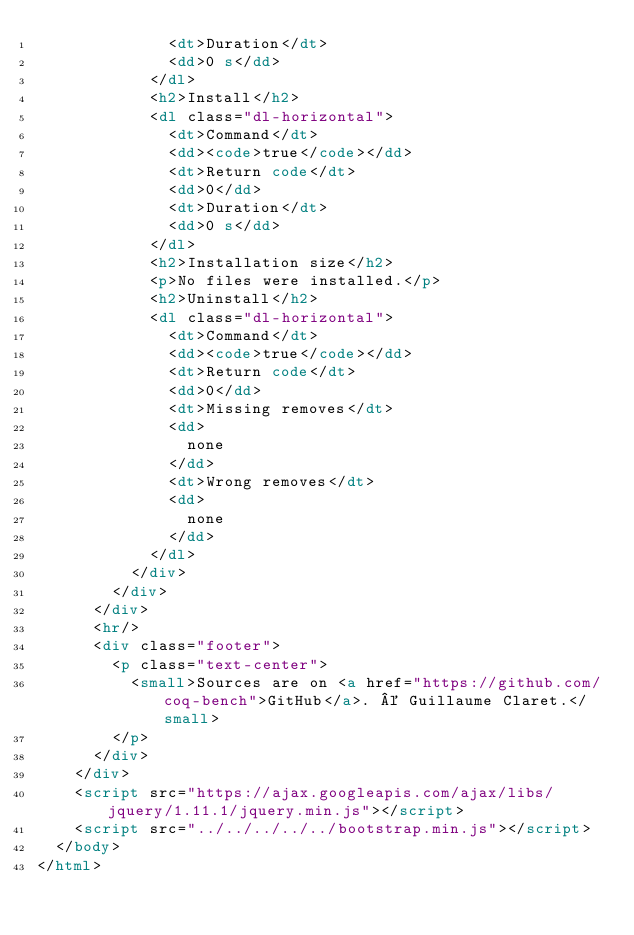<code> <loc_0><loc_0><loc_500><loc_500><_HTML_>              <dt>Duration</dt>
              <dd>0 s</dd>
            </dl>
            <h2>Install</h2>
            <dl class="dl-horizontal">
              <dt>Command</dt>
              <dd><code>true</code></dd>
              <dt>Return code</dt>
              <dd>0</dd>
              <dt>Duration</dt>
              <dd>0 s</dd>
            </dl>
            <h2>Installation size</h2>
            <p>No files were installed.</p>
            <h2>Uninstall</h2>
            <dl class="dl-horizontal">
              <dt>Command</dt>
              <dd><code>true</code></dd>
              <dt>Return code</dt>
              <dd>0</dd>
              <dt>Missing removes</dt>
              <dd>
                none
              </dd>
              <dt>Wrong removes</dt>
              <dd>
                none
              </dd>
            </dl>
          </div>
        </div>
      </div>
      <hr/>
      <div class="footer">
        <p class="text-center">
          <small>Sources are on <a href="https://github.com/coq-bench">GitHub</a>. © Guillaume Claret.</small>
        </p>
      </div>
    </div>
    <script src="https://ajax.googleapis.com/ajax/libs/jquery/1.11.1/jquery.min.js"></script>
    <script src="../../../../../bootstrap.min.js"></script>
  </body>
</html>
</code> 